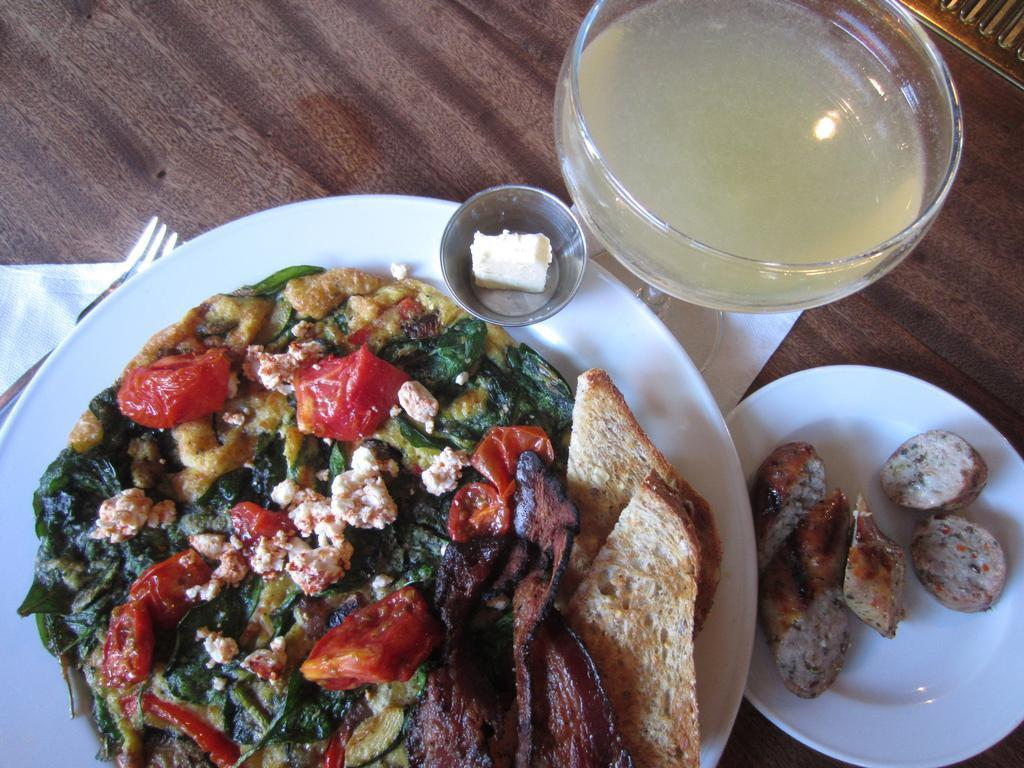What piece of furniture is present in the image? There is a table in the image. What is placed on the table? There are two plants, plates, and a bowl on the table. What is in the plates? There is food in the plates. What is in the bowl? There is a liquid in the bowl. How many screws can be seen holding the brick in place in the image? There are no screws or bricks present in the image. 